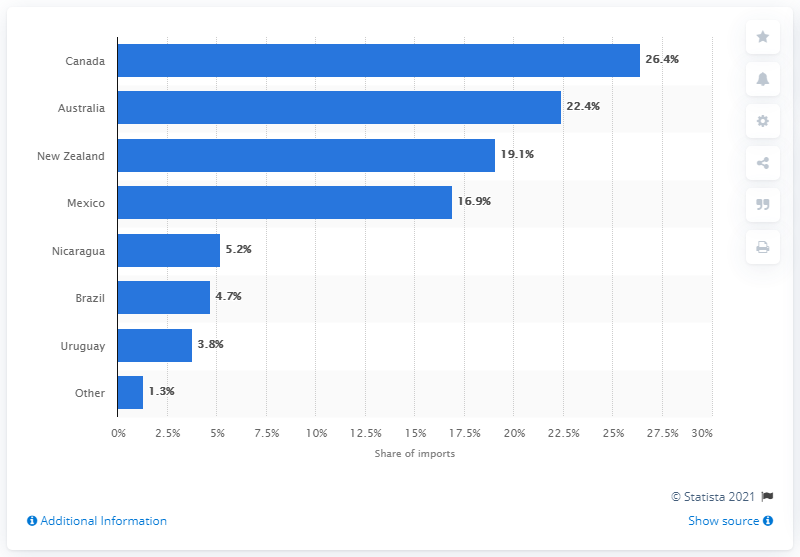Give some essential details in this illustration. In 2018, 26.4% of beef imports to the United States came from Canada. 